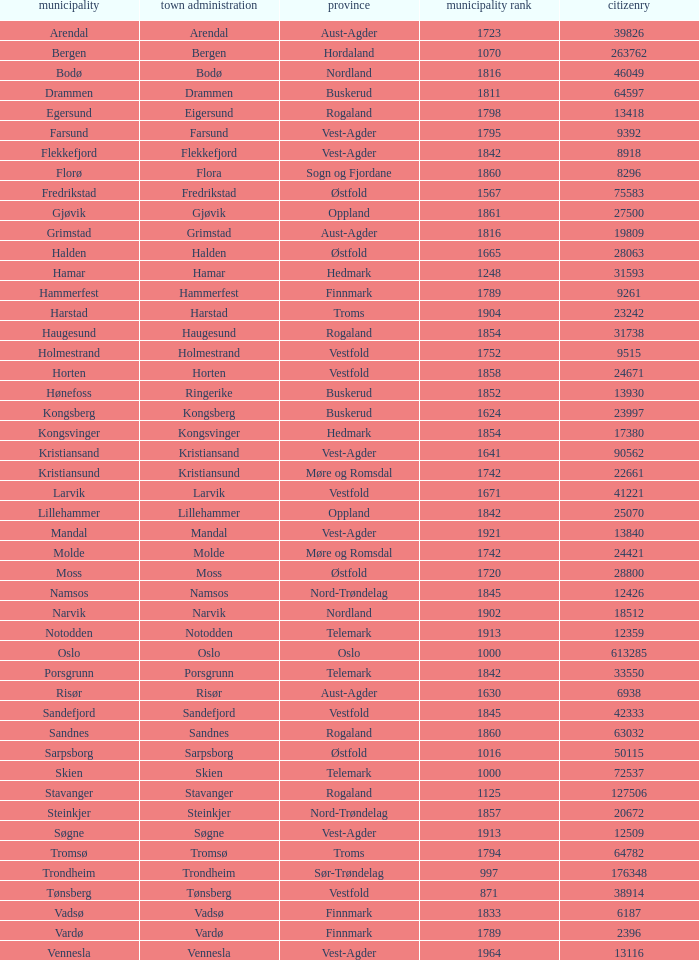In which county is the city/town of Halden located? Østfold. 